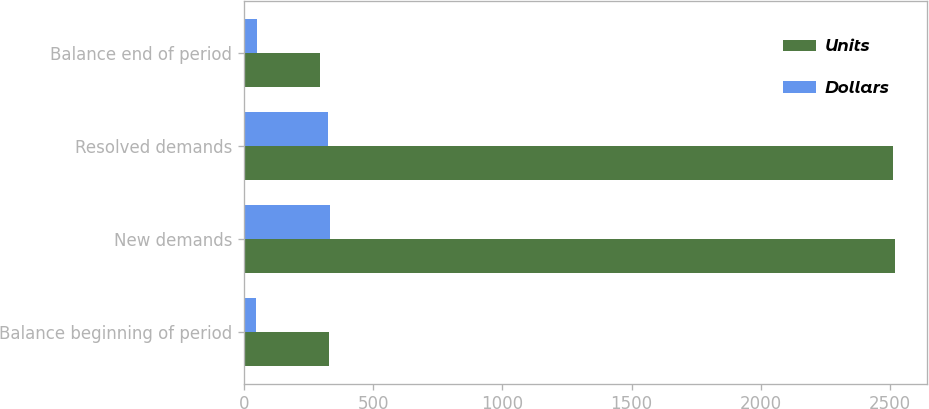<chart> <loc_0><loc_0><loc_500><loc_500><stacked_bar_chart><ecel><fcel>Balance beginning of period<fcel>New demands<fcel>Resolved demands<fcel>Balance end of period<nl><fcel>Units<fcel>328<fcel>2519<fcel>2511<fcel>294<nl><fcel>Dollars<fcel>47<fcel>333<fcel>325<fcel>48<nl></chart> 